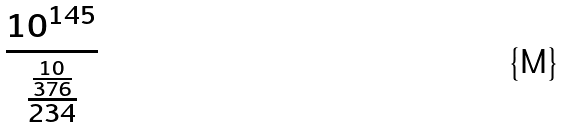<formula> <loc_0><loc_0><loc_500><loc_500>\frac { 1 0 ^ { 1 4 5 } } { \frac { \frac { 1 0 } { 3 7 6 } } { 2 3 4 } }</formula> 